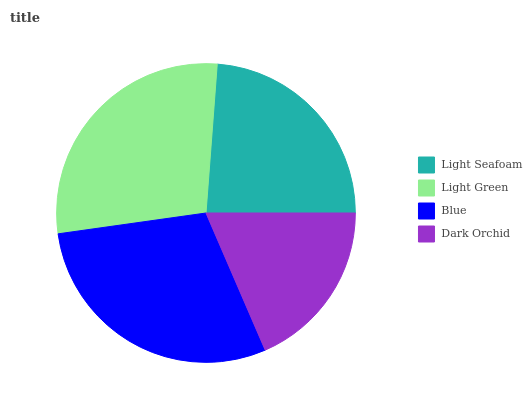Is Dark Orchid the minimum?
Answer yes or no. Yes. Is Blue the maximum?
Answer yes or no. Yes. Is Light Green the minimum?
Answer yes or no. No. Is Light Green the maximum?
Answer yes or no. No. Is Light Green greater than Light Seafoam?
Answer yes or no. Yes. Is Light Seafoam less than Light Green?
Answer yes or no. Yes. Is Light Seafoam greater than Light Green?
Answer yes or no. No. Is Light Green less than Light Seafoam?
Answer yes or no. No. Is Light Green the high median?
Answer yes or no. Yes. Is Light Seafoam the low median?
Answer yes or no. Yes. Is Dark Orchid the high median?
Answer yes or no. No. Is Blue the low median?
Answer yes or no. No. 